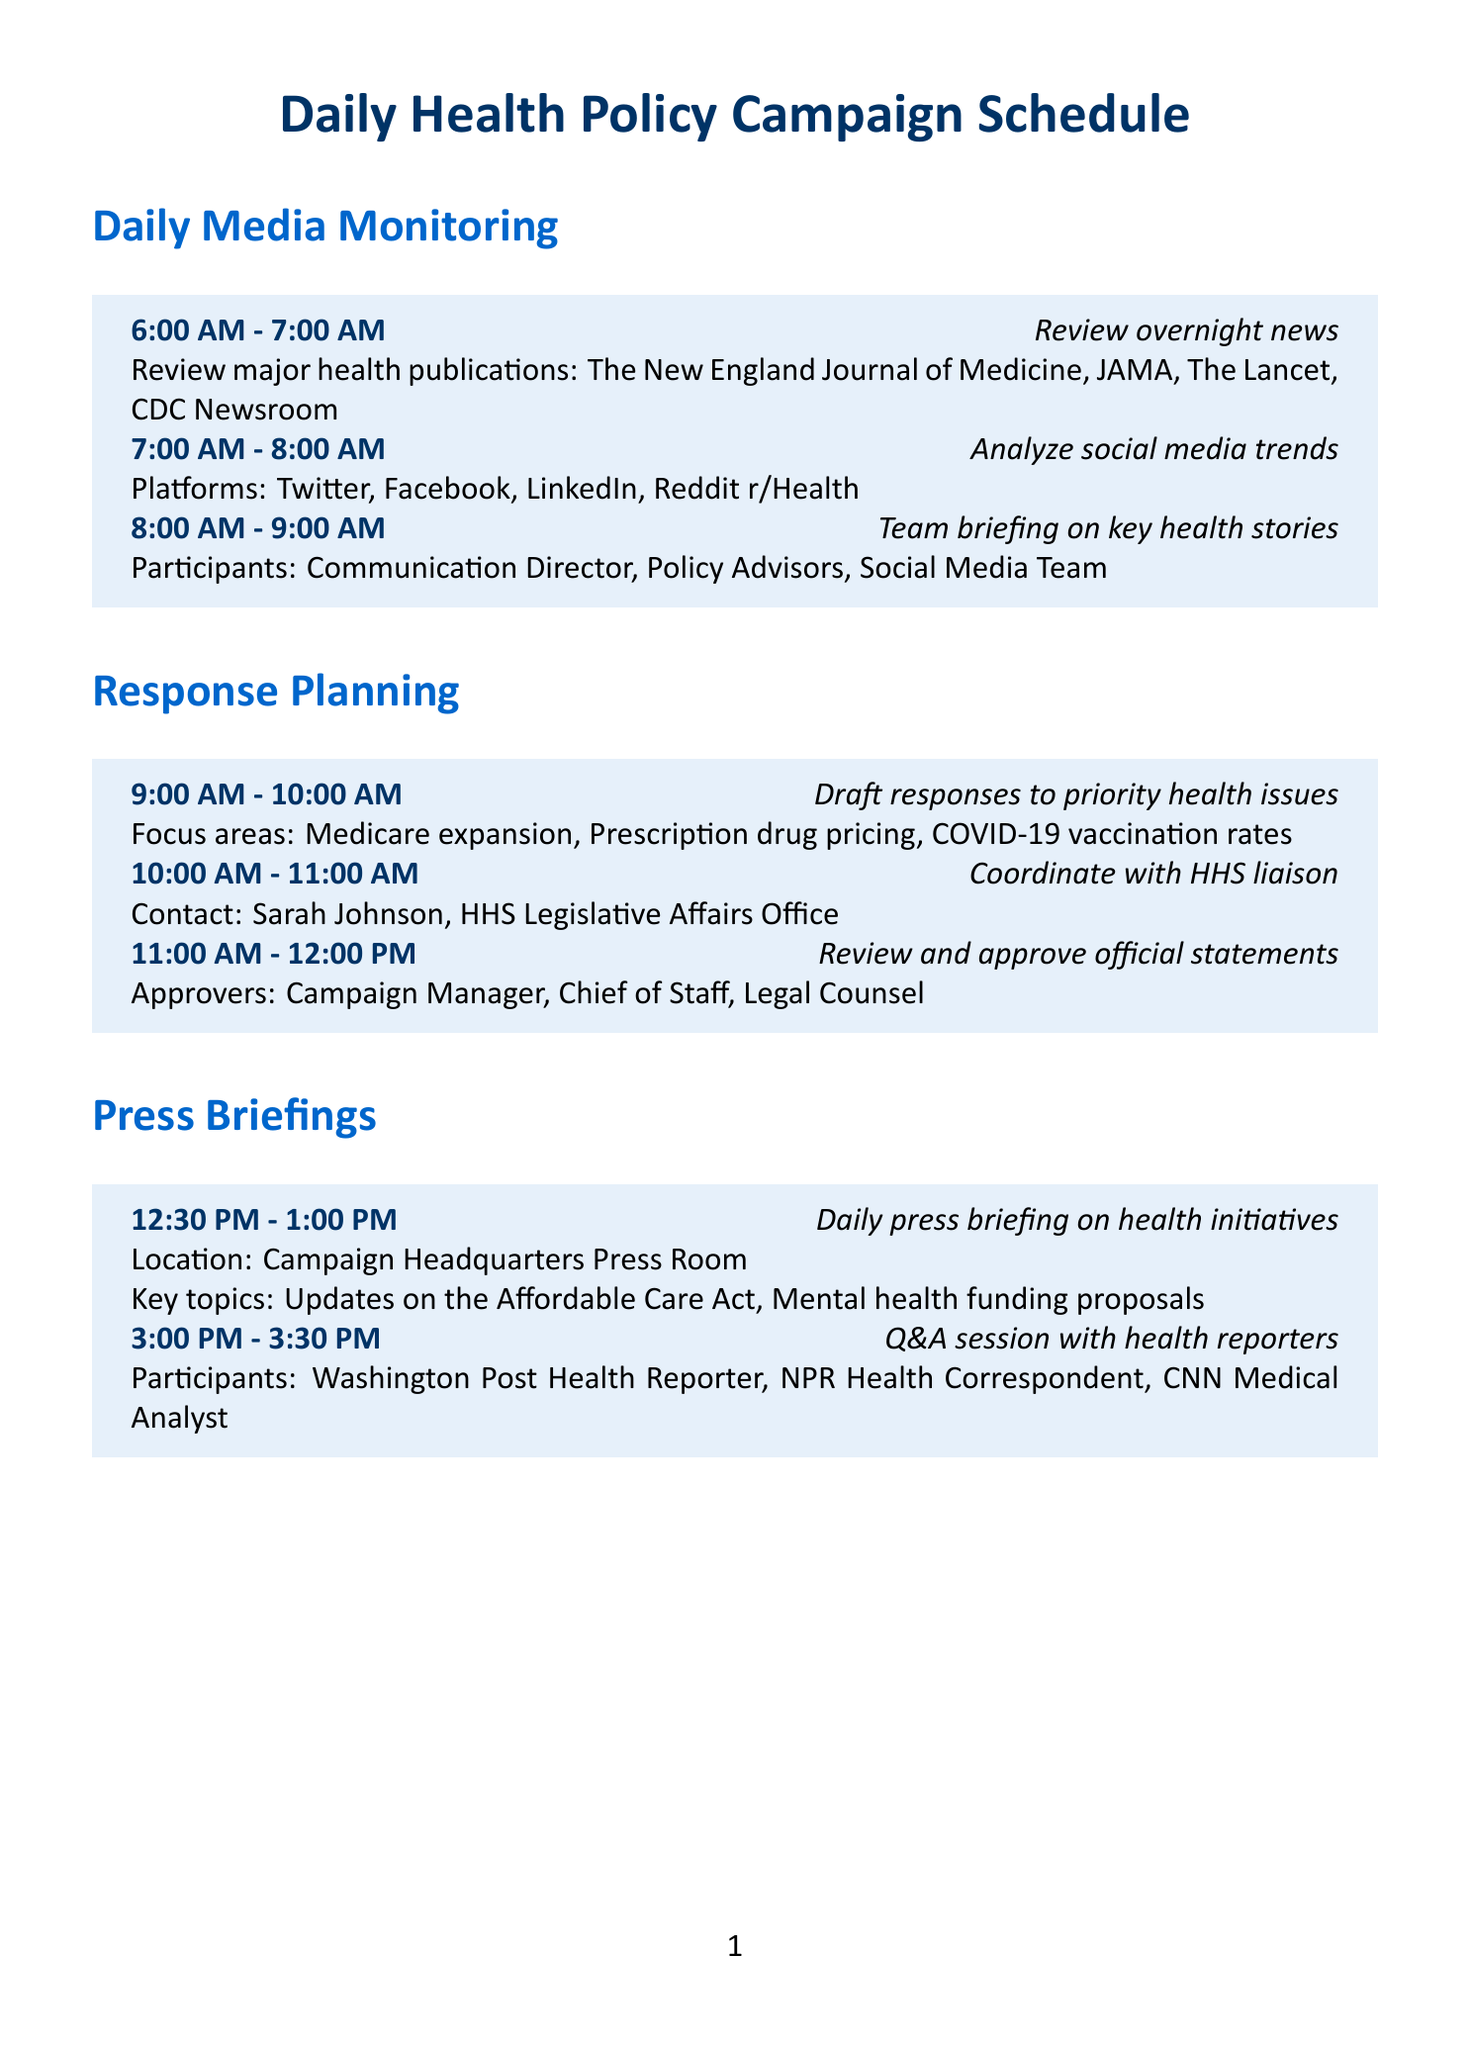What time does the daily press briefing start? The daily press briefing starts at 12:30 PM.
Answer: 12:30 PM Who approves the official statements? The approvers of the official statements include the Campaign Manager, Chief of Staff, and Legal Counsel.
Answer: Campaign Manager, Chief of Staff, Legal Counsel What are the focus areas for drafting responses? The focus areas for drafting responses include Medicare expansion, Prescription drug pricing, and COVID-19 vaccination rates.
Answer: Medicare expansion, Prescription drug pricing, COVID-19 vaccination rates How long is the Q&A session with health reporters? The Q&A session with health reporters lasts for 30 minutes, from 3:00 PM to 3:30 PM.
Answer: 30 minutes What is reviewed during the legislative strategy meeting? The legislative strategy meeting involves reviewing health-related bill progress, specifically H.R. 3 and S. 1932.
Answer: H.R. 3, S. 1932 Who should be contacted to coordinate with the Senate Health Committee? To coordinate with the Senate Health Committee, the contact person is Senator Patty Murray's office.
Answer: Senator Patty Murray's office What is the primary deliverable at the end of the day? The primary deliverable at the end of the day includes a daily health news digest.
Answer: Daily health news digest What time is the end of day wrap-up scheduled? The end of day wrap-up is scheduled from 5:00 PM to 6:00 PM.
Answer: 5:00 PM - 6:00 PM 